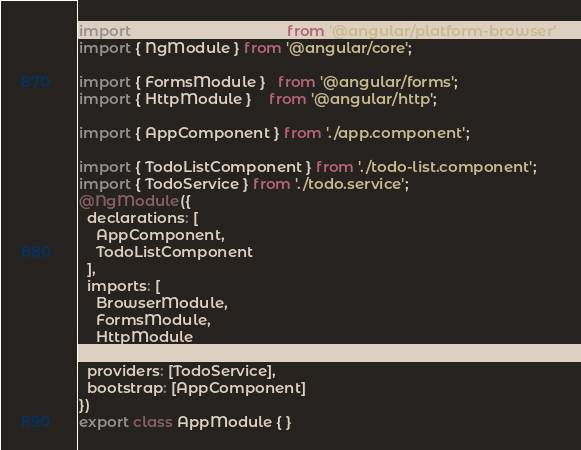Convert code to text. <code><loc_0><loc_0><loc_500><loc_500><_TypeScript_>import { BrowserModule } from '@angular/platform-browser';
import { NgModule } from '@angular/core';

import { FormsModule }   from '@angular/forms';
import { HttpModule }    from '@angular/http';

import { AppComponent } from './app.component';

import { TodoListComponent } from './todo-list.component';
import { TodoService } from './todo.service';
@NgModule({
  declarations: [
    AppComponent,
    TodoListComponent
  ],
  imports: [
    BrowserModule,
    FormsModule,
    HttpModule
  ],
  providers: [TodoService],
  bootstrap: [AppComponent]
})
export class AppModule { }
</code> 